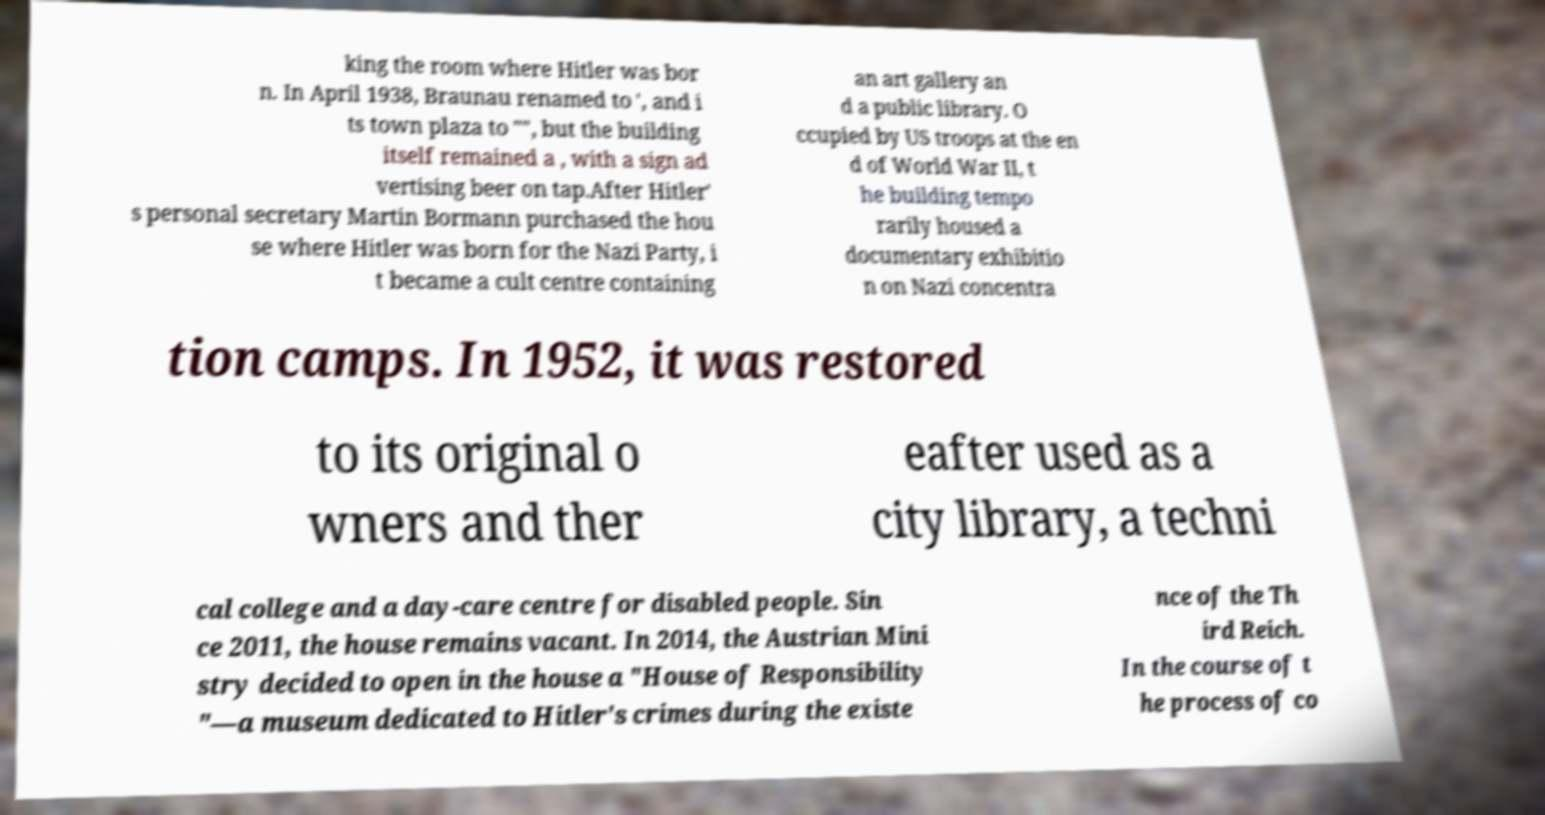Could you assist in decoding the text presented in this image and type it out clearly? king the room where Hitler was bor n. In April 1938, Braunau renamed to ', and i ts town plaza to "", but the building itself remained a , with a sign ad vertising beer on tap.After Hitler' s personal secretary Martin Bormann purchased the hou se where Hitler was born for the Nazi Party, i t became a cult centre containing an art gallery an d a public library. O ccupied by US troops at the en d of World War II, t he building tempo rarily housed a documentary exhibitio n on Nazi concentra tion camps. In 1952, it was restored to its original o wners and ther eafter used as a city library, a techni cal college and a day-care centre for disabled people. Sin ce 2011, the house remains vacant. In 2014, the Austrian Mini stry decided to open in the house a "House of Responsibility "—a museum dedicated to Hitler's crimes during the existe nce of the Th ird Reich. In the course of t he process of co 